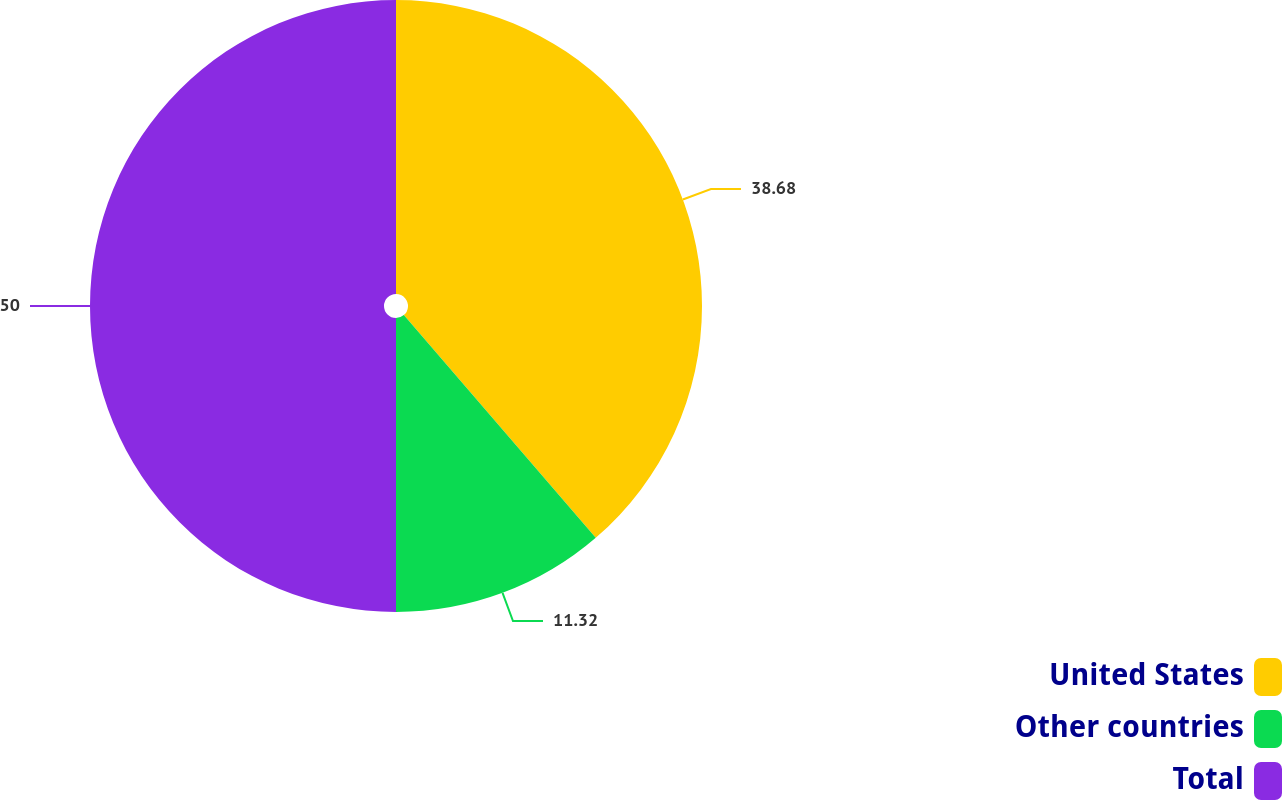<chart> <loc_0><loc_0><loc_500><loc_500><pie_chart><fcel>United States<fcel>Other countries<fcel>Total<nl><fcel>38.68%<fcel>11.32%<fcel>50.0%<nl></chart> 